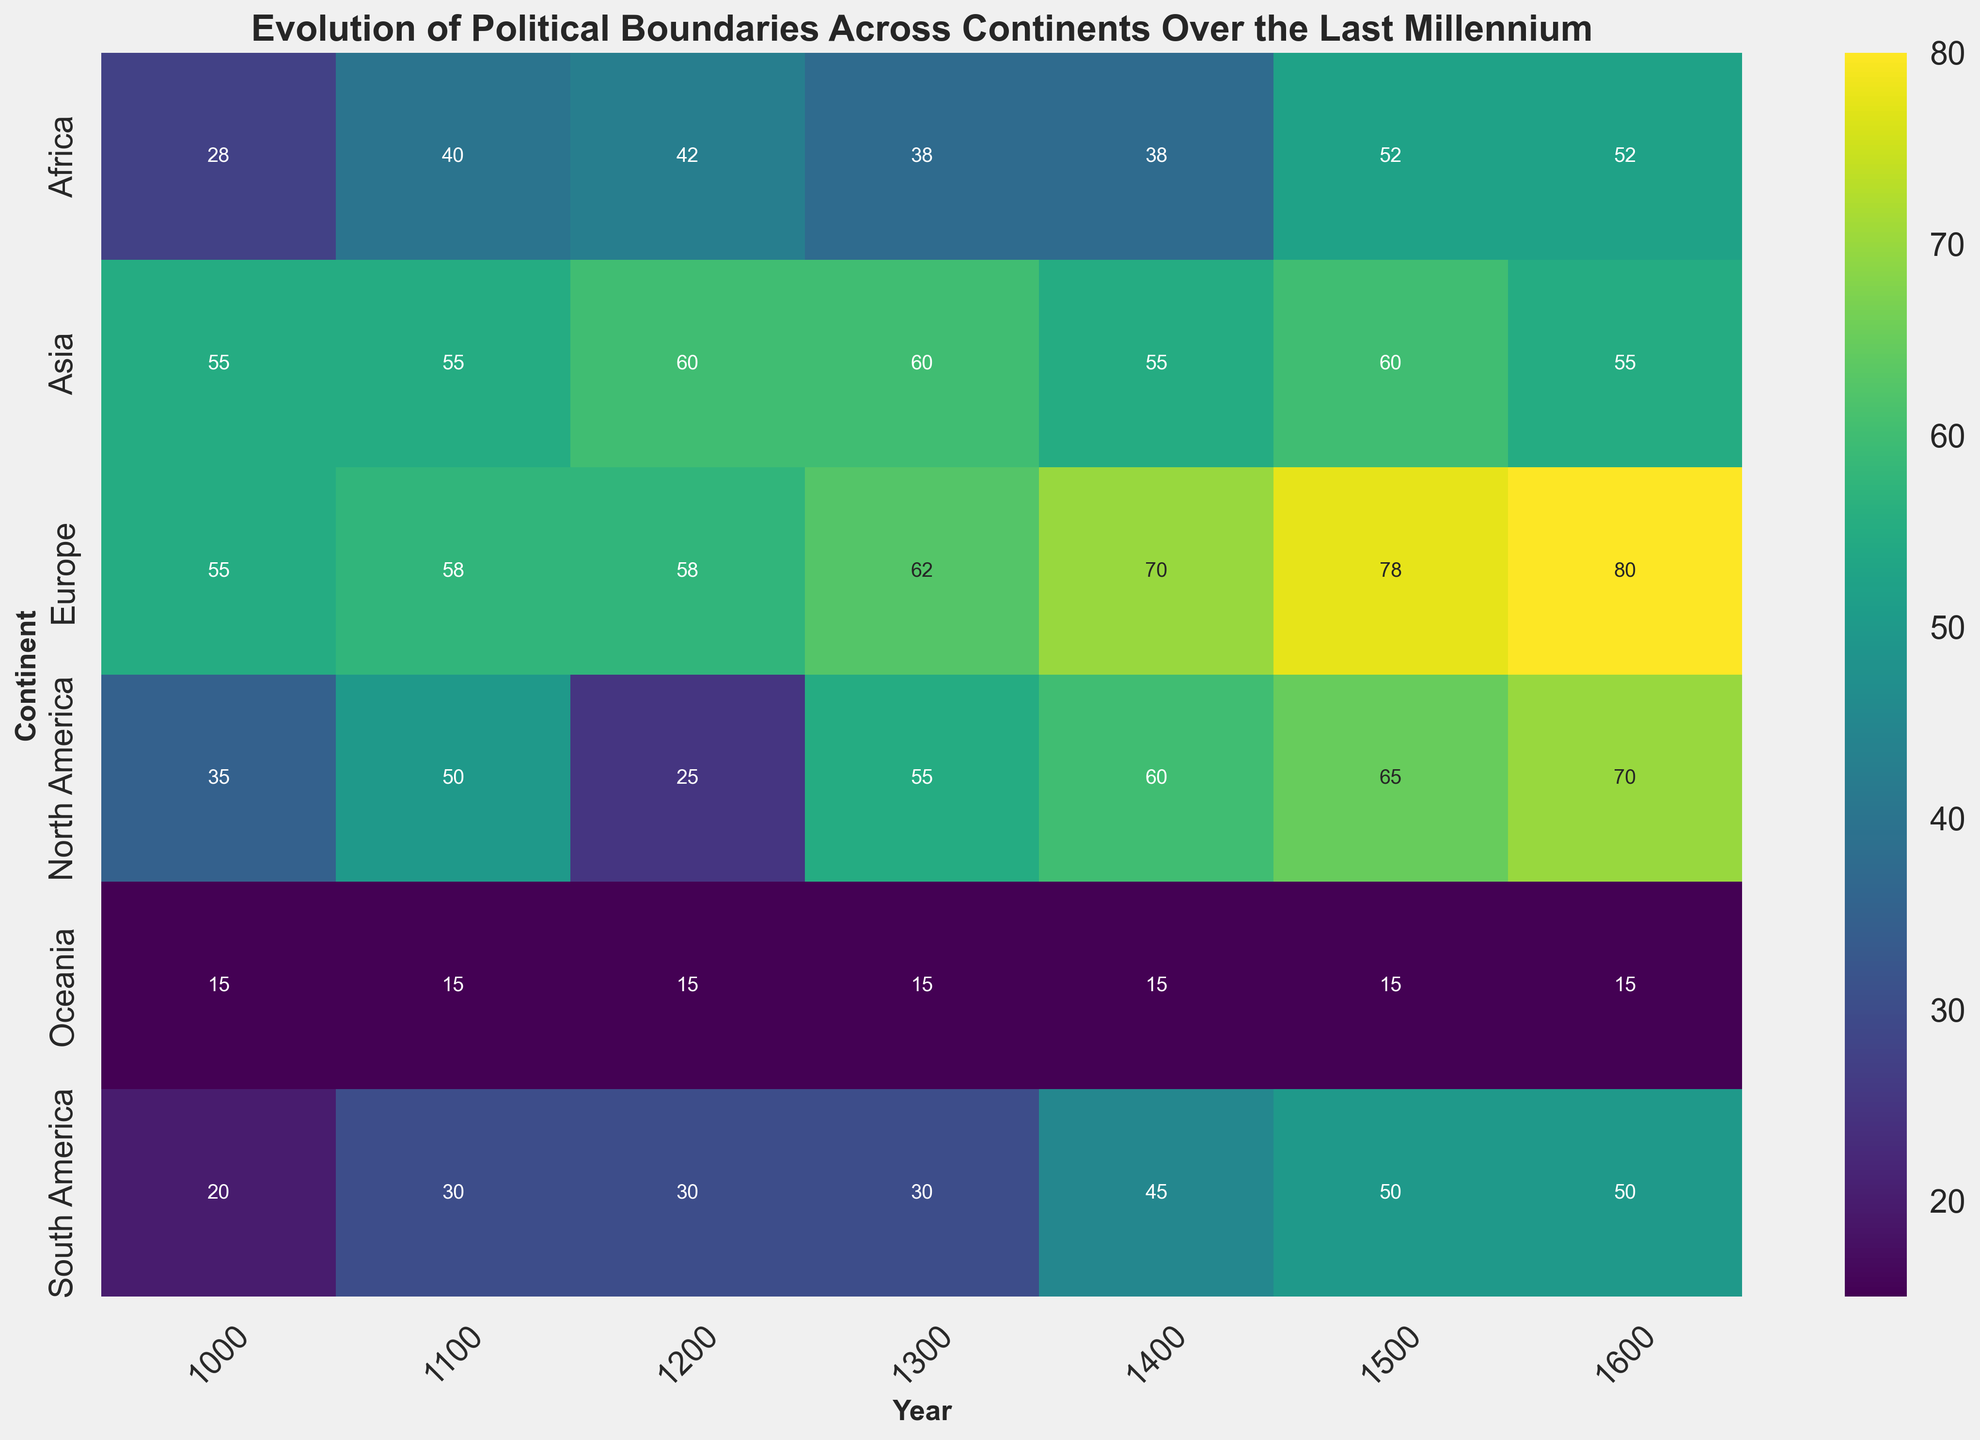Which continent showed the highest boundary change around 1600? Identify the darkest-colored cell (indicating the highest boundary change) in the 1600 column and locate which row (continent) it corresponds to. The value is highest in Western Europe around 1600.
Answer: Western Europe Between 1000 and 1400, which continent saw a consistent increase in boundary changes? Look for a continent (row) where the values in the columns (years) from 1000 to 1400 consistently increase. Western Europe shows an increase from 50 in 1000 to 65 in 1400.
Answer: Western Europe Comparing North America and South America in 1100, which had a more stable political boundary based on boundary change? Compare the numerical values in the 1100 column for North America and South America. The values are 50 for North America and 30 for South America. Lower values indicate more stability.
Answer: South America Which continents showed no change in boundary metrics from 1100 to 1400? Identify rows where the data in the columns for 1100 and 1400 have the same value. Oceania has values of 15 consistently from 1100 to 1400, indicating no change.
Answer: Oceania In 1500, which region experienced the second highest boundary change in Africa? Within the 1500 column, look at the Africa rows. The values are 60 for North Africa and 45 for West Africa. The second highest is 45 in West Africa.
Answer: West Africa Calculate the average boundary change for Europe across all timelines. Add up all the values of boundary changes for Europe and divide by the number of years. Europe values are (50+55+60+55+80+85) across 1000 to 1600. The sum is 385, and the average is 385/6 = 64.2
Answer: 64.2 How does the boundary change in East Asia differ from South Asia between 1300 and 1600? Compare the East Asia and South Asia values for the years 1300, 1400, 1500, and 1600. East Asia's values are 70, 70, 70, and 60. South Asia's values are 50, 40, 50, and 50. East Asia has a higher initial value but shows a decrease by 1600, whereas South Asia shows less variation.
Answer: East Asia starts higher but decreases; South Asia is more stable Which year had the highest average boundary change across all continents? For each year (column), calculate the sum of the values for all continents and divide by the number of continents, comparing the results. 1600 has the highest values appearing consistently high across continents.
Answer: 1600 